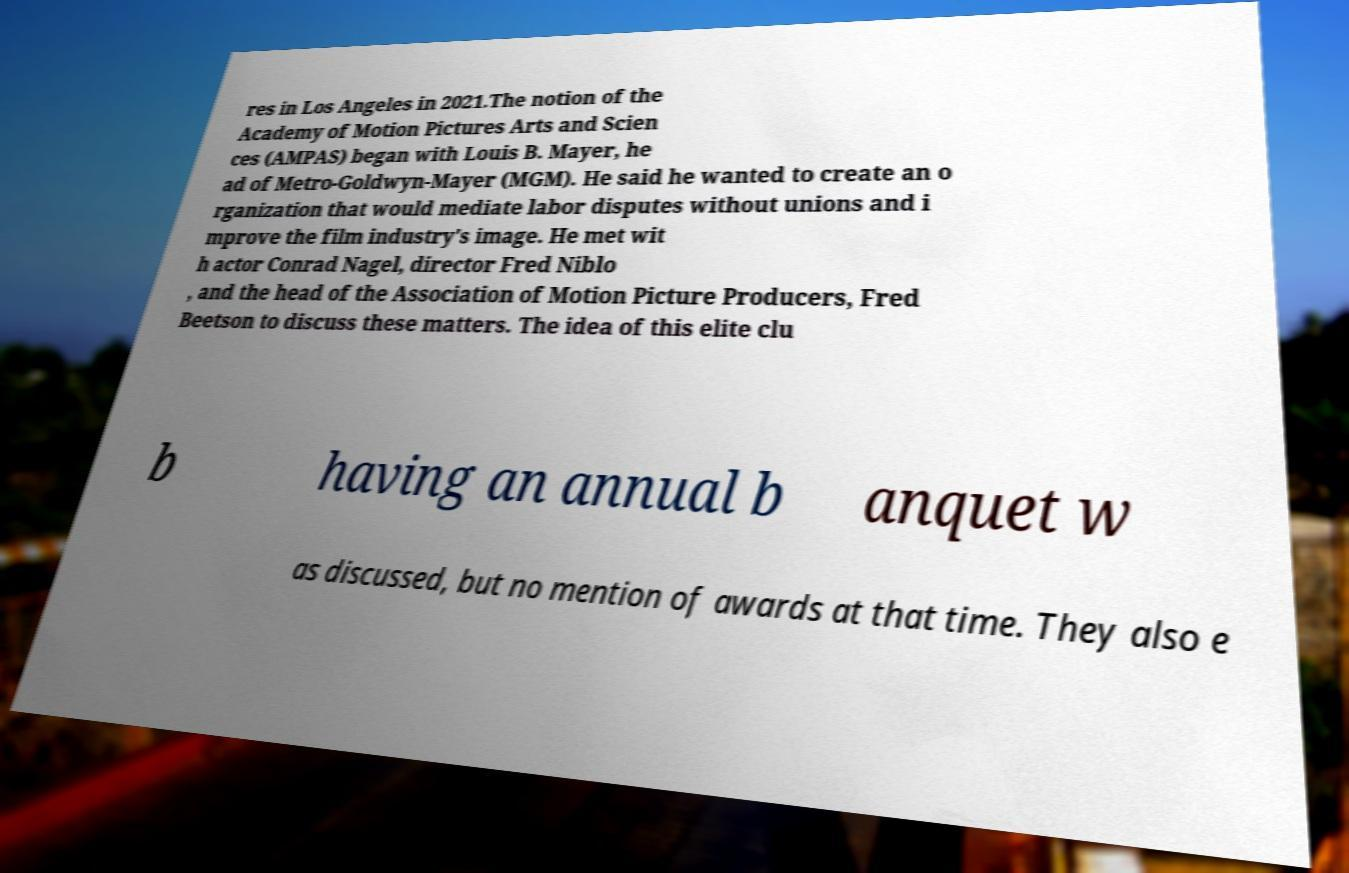Could you assist in decoding the text presented in this image and type it out clearly? res in Los Angeles in 2021.The notion of the Academy of Motion Pictures Arts and Scien ces (AMPAS) began with Louis B. Mayer, he ad of Metro-Goldwyn-Mayer (MGM). He said he wanted to create an o rganization that would mediate labor disputes without unions and i mprove the film industry's image. He met wit h actor Conrad Nagel, director Fred Niblo , and the head of the Association of Motion Picture Producers, Fred Beetson to discuss these matters. The idea of this elite clu b having an annual b anquet w as discussed, but no mention of awards at that time. They also e 